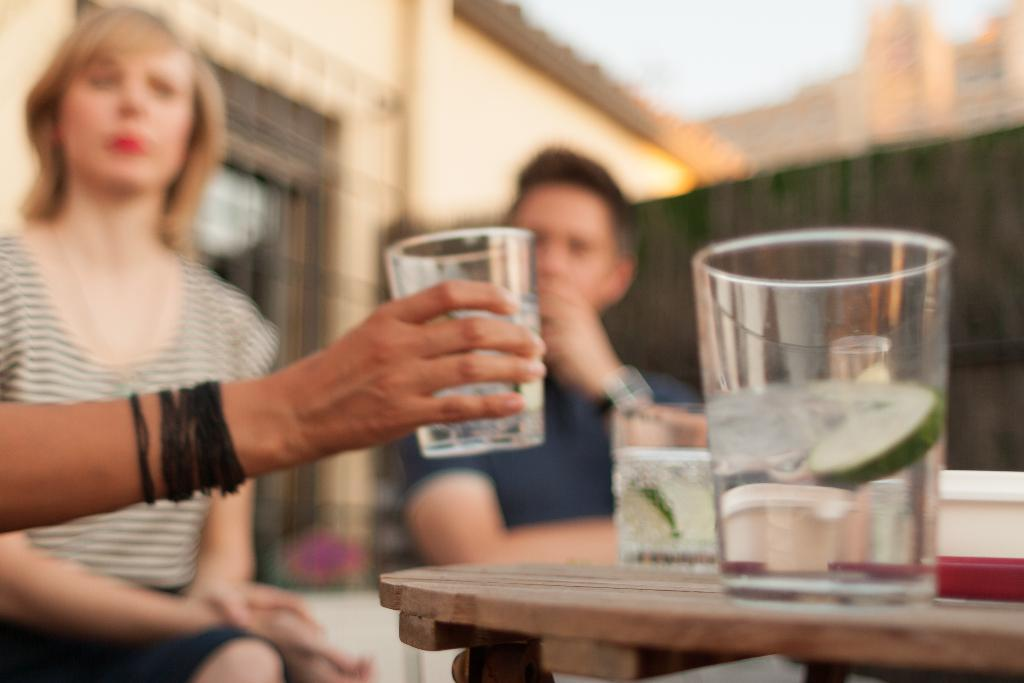What is the person holding in the image? The person is holding a glass in the image. What are the two individuals in the image doing? There is a woman sitting in a chair and a man sitting in a chair in the image. What can be seen on the table in the image? There is a glass containing water and lemon on the table in the image. What is visible in the background of the image? There is a building and the sky visible in the background of the image. What type of treatment is being administered to the person's wound on their legs in the image? There is no mention of a wound or treatment in the image; it only shows a person holding a glass, a woman and a man sitting in chairs, a table with a glass containing water and lemon, and a building and sky in the background. 